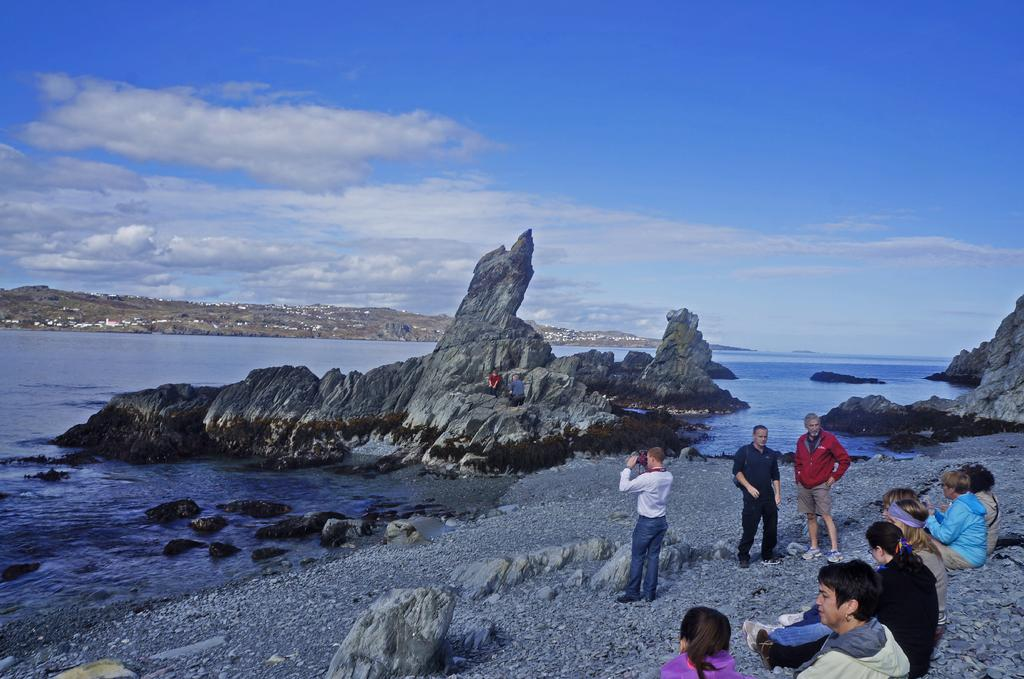What is the main subject in the foreground of the image? There is a group of people in the foreground of the image. Where are the people located in relation to the ground? The group of people is on the ground. What can be seen in the background of the image? There are mountains, water, trees, houses, and the sky visible in the background of the image. What might suggest the location of the image? The image may have been taken near the ocean, as there is water visible in the background. What type of comfort can be seen being provided by the camera in the image? There is no camera present in the image, and therefore no comfort can be provided by it. What arithmetic problem can be solved using the houses in the image? There is no arithmetic problem related to the houses in the image, as they are simply part of the background scenery. 